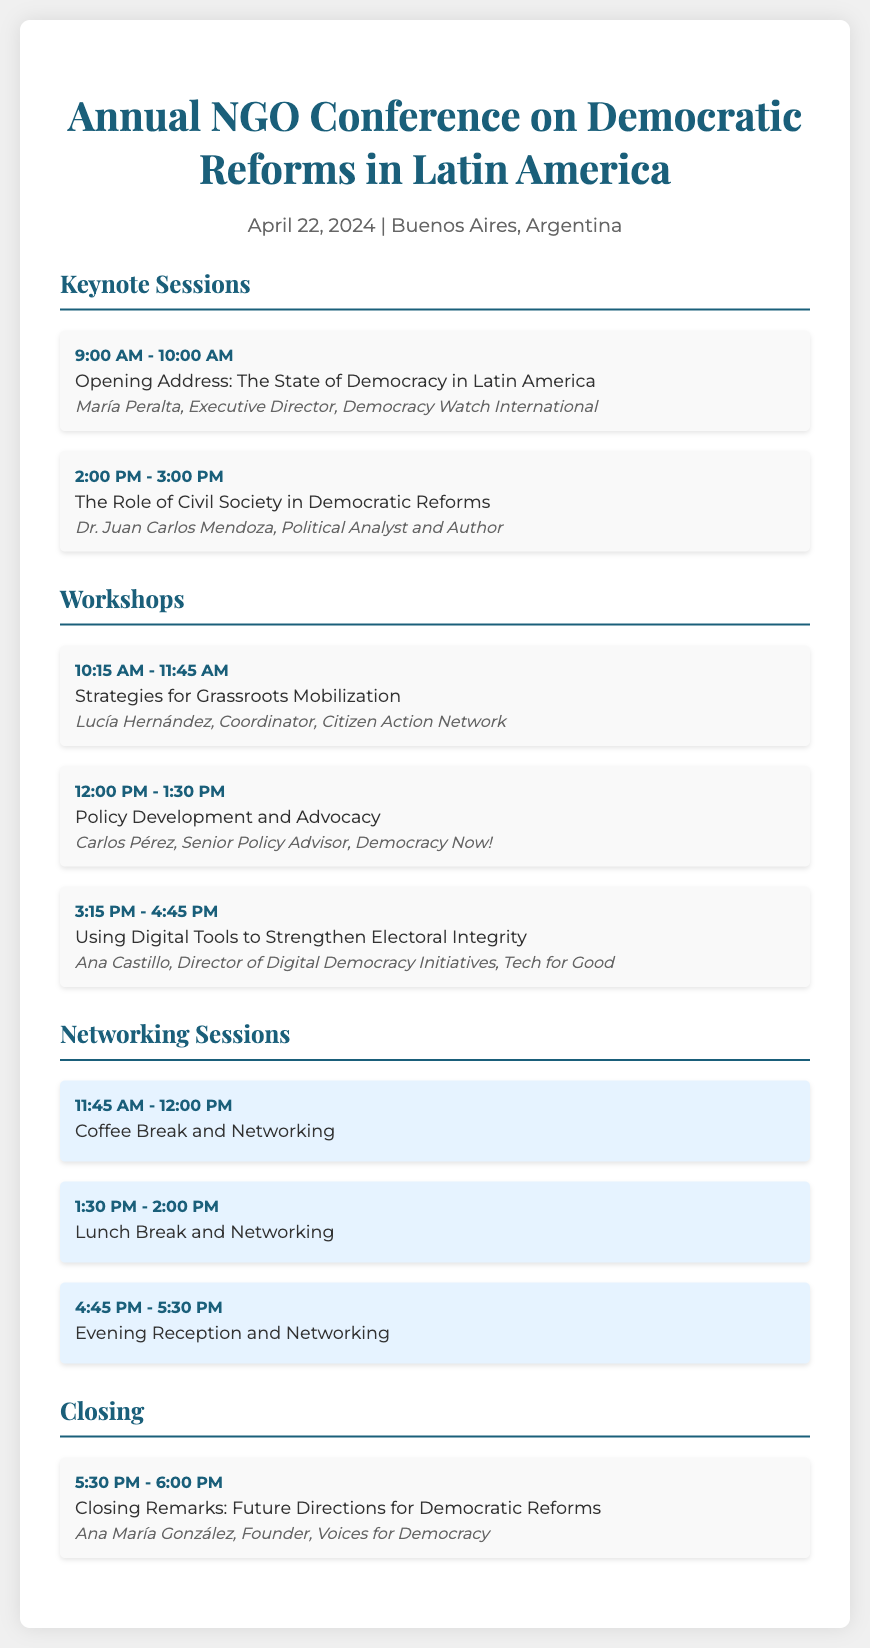What is the date of the conference? The date of the conference is stated in the event details section of the document.
Answer: April 22, 2024 Who is the keynote speaker for the opening address? The keynote speaker for the opening address is mentioned in the Keynote Sessions section of the document.
Answer: María Peralta What is the duration of the workshop on grassroots mobilization? The duration of the workshop can be calculated from the event time provided in the workshops section.
Answer: 1 hour 30 minutes What time does the evening reception and networking session start? The start time is indicated in the Networking Sessions section of the document.
Answer: 4:45 PM How many workshops are listed in the document? The total number of workshops can be counted from the workshops section.
Answer: 3 What is the title of the closing remarks session? The title is found at the end of the sections in the document under closing.
Answer: Closing Remarks: Future Directions for Democratic Reforms Who will lead the workshop on digital tools for electoral integrity? The leader of the workshop is listed in the workshops section of the document.
Answer: Ana Castillo What is the color theme of the networking sessions? The background color for the networking events is described in the styling section of the document.
Answer: Light blue What is the time allocated for the lunch break and networking? The time for the lunch break is specified in the Networking Sessions section of the document.
Answer: 1:30 PM - 2:00 PM 